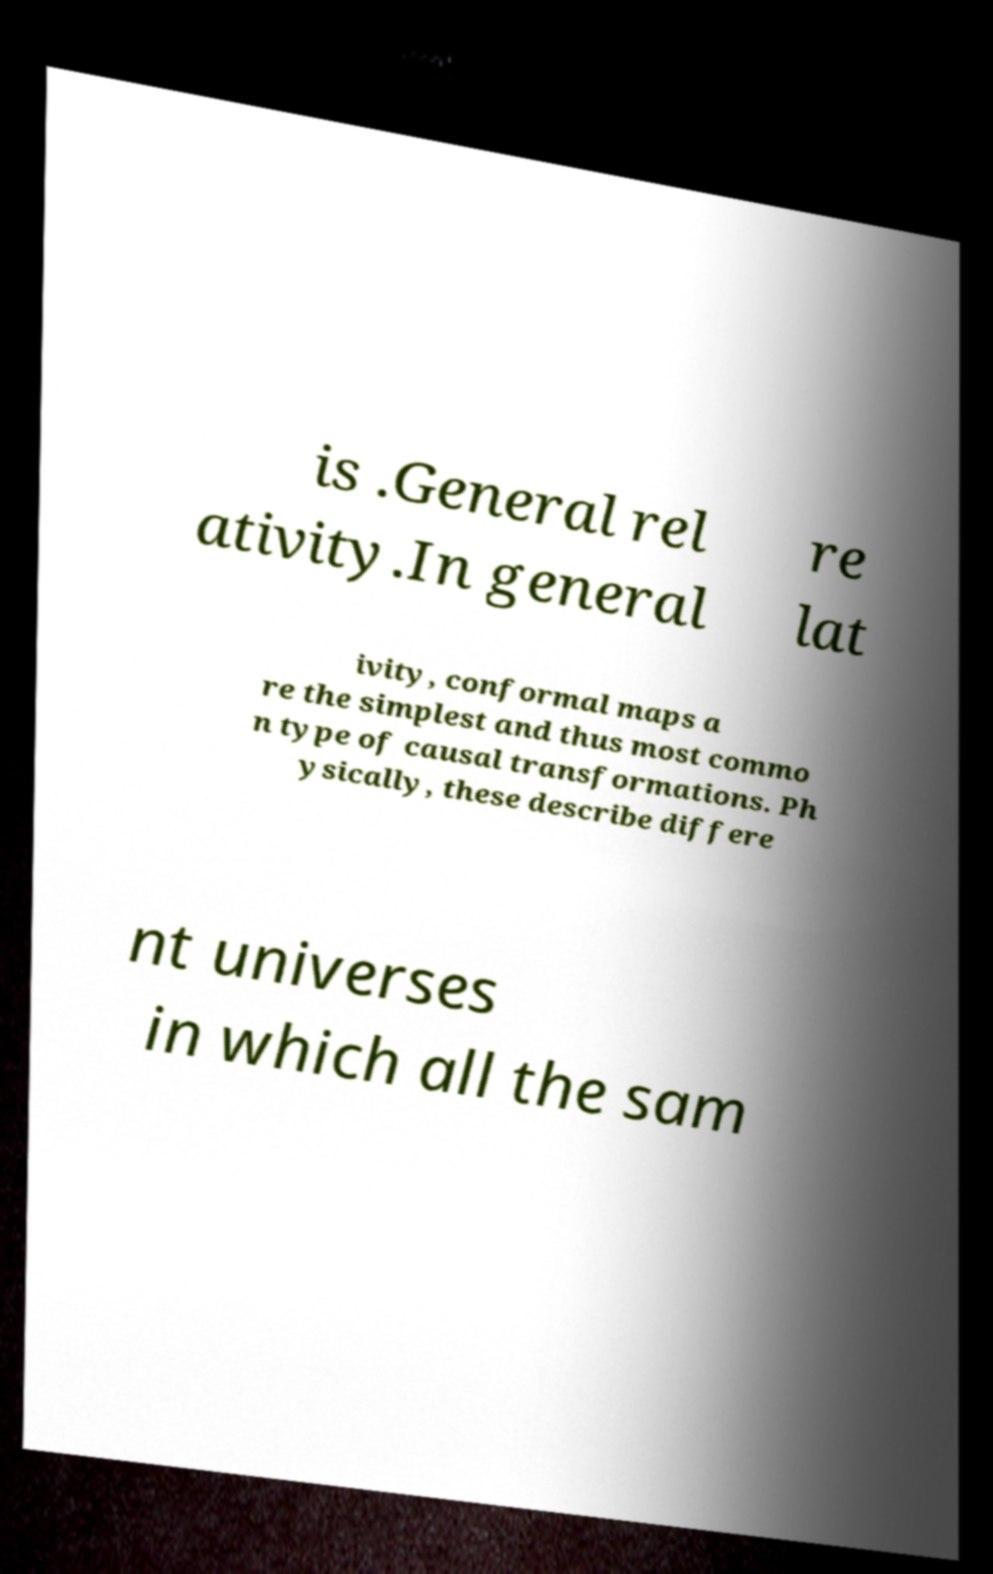Can you read and provide the text displayed in the image?This photo seems to have some interesting text. Can you extract and type it out for me? is .General rel ativity.In general re lat ivity, conformal maps a re the simplest and thus most commo n type of causal transformations. Ph ysically, these describe differe nt universes in which all the sam 